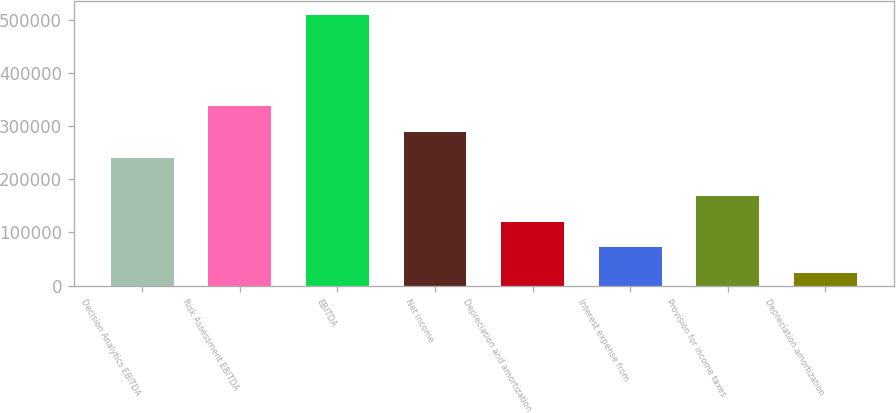Convert chart to OTSL. <chart><loc_0><loc_0><loc_500><loc_500><bar_chart><fcel>Decision Analytics EBITDA<fcel>Risk Assessment EBITDA<fcel>EBITDA<fcel>Net income<fcel>Depreciation and amortization<fcel>Interest expense from<fcel>Provision for income taxes<fcel>Depreciation amortization<nl><fcel>240623<fcel>337921<fcel>509440<fcel>289272<fcel>120250<fcel>71600.8<fcel>168898<fcel>22952<nl></chart> 